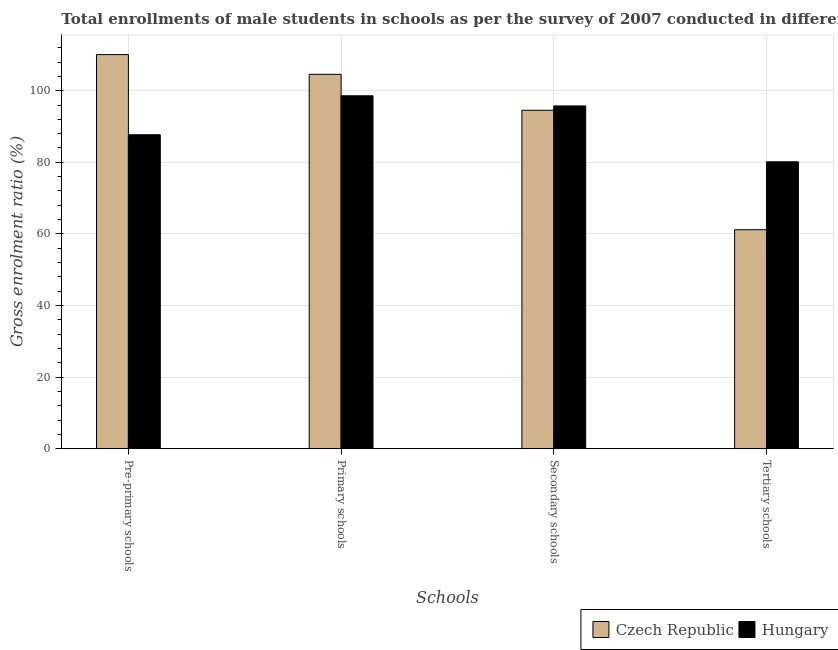How many groups of bars are there?
Offer a very short reply. 4. Are the number of bars on each tick of the X-axis equal?
Offer a very short reply. Yes. How many bars are there on the 1st tick from the right?
Keep it short and to the point. 2. What is the label of the 4th group of bars from the left?
Your answer should be compact. Tertiary schools. What is the gross enrolment ratio(male) in primary schools in Hungary?
Ensure brevity in your answer.  98.58. Across all countries, what is the maximum gross enrolment ratio(male) in primary schools?
Keep it short and to the point. 104.58. Across all countries, what is the minimum gross enrolment ratio(male) in pre-primary schools?
Make the answer very short. 87.69. In which country was the gross enrolment ratio(male) in pre-primary schools maximum?
Ensure brevity in your answer.  Czech Republic. In which country was the gross enrolment ratio(male) in tertiary schools minimum?
Your response must be concise. Czech Republic. What is the total gross enrolment ratio(male) in primary schools in the graph?
Give a very brief answer. 203.16. What is the difference between the gross enrolment ratio(male) in secondary schools in Czech Republic and that in Hungary?
Keep it short and to the point. -1.21. What is the difference between the gross enrolment ratio(male) in primary schools in Czech Republic and the gross enrolment ratio(male) in secondary schools in Hungary?
Offer a very short reply. 8.83. What is the average gross enrolment ratio(male) in pre-primary schools per country?
Keep it short and to the point. 98.89. What is the difference between the gross enrolment ratio(male) in tertiary schools and gross enrolment ratio(male) in pre-primary schools in Hungary?
Your answer should be compact. -7.56. What is the ratio of the gross enrolment ratio(male) in secondary schools in Czech Republic to that in Hungary?
Your answer should be compact. 0.99. Is the gross enrolment ratio(male) in tertiary schools in Czech Republic less than that in Hungary?
Your answer should be very brief. Yes. Is the difference between the gross enrolment ratio(male) in tertiary schools in Czech Republic and Hungary greater than the difference between the gross enrolment ratio(male) in pre-primary schools in Czech Republic and Hungary?
Provide a short and direct response. No. What is the difference between the highest and the second highest gross enrolment ratio(male) in pre-primary schools?
Your answer should be compact. 22.39. What is the difference between the highest and the lowest gross enrolment ratio(male) in secondary schools?
Offer a terse response. 1.21. What does the 1st bar from the left in Pre-primary schools represents?
Ensure brevity in your answer.  Czech Republic. What does the 1st bar from the right in Tertiary schools represents?
Give a very brief answer. Hungary. Is it the case that in every country, the sum of the gross enrolment ratio(male) in pre-primary schools and gross enrolment ratio(male) in primary schools is greater than the gross enrolment ratio(male) in secondary schools?
Provide a short and direct response. Yes. How many bars are there?
Your answer should be compact. 8. Are all the bars in the graph horizontal?
Give a very brief answer. No. How many countries are there in the graph?
Offer a very short reply. 2. Does the graph contain any zero values?
Keep it short and to the point. No. Does the graph contain grids?
Make the answer very short. Yes. Where does the legend appear in the graph?
Ensure brevity in your answer.  Bottom right. How are the legend labels stacked?
Make the answer very short. Horizontal. What is the title of the graph?
Offer a very short reply. Total enrollments of male students in schools as per the survey of 2007 conducted in different countries. Does "Isle of Man" appear as one of the legend labels in the graph?
Your answer should be compact. No. What is the label or title of the X-axis?
Ensure brevity in your answer.  Schools. What is the Gross enrolment ratio (%) in Czech Republic in Pre-primary schools?
Your response must be concise. 110.09. What is the Gross enrolment ratio (%) in Hungary in Pre-primary schools?
Provide a succinct answer. 87.69. What is the Gross enrolment ratio (%) in Czech Republic in Primary schools?
Make the answer very short. 104.58. What is the Gross enrolment ratio (%) in Hungary in Primary schools?
Offer a terse response. 98.58. What is the Gross enrolment ratio (%) of Czech Republic in Secondary schools?
Your response must be concise. 94.53. What is the Gross enrolment ratio (%) in Hungary in Secondary schools?
Ensure brevity in your answer.  95.74. What is the Gross enrolment ratio (%) of Czech Republic in Tertiary schools?
Make the answer very short. 61.17. What is the Gross enrolment ratio (%) of Hungary in Tertiary schools?
Your response must be concise. 80.14. Across all Schools, what is the maximum Gross enrolment ratio (%) of Czech Republic?
Ensure brevity in your answer.  110.09. Across all Schools, what is the maximum Gross enrolment ratio (%) in Hungary?
Give a very brief answer. 98.58. Across all Schools, what is the minimum Gross enrolment ratio (%) in Czech Republic?
Provide a short and direct response. 61.17. Across all Schools, what is the minimum Gross enrolment ratio (%) in Hungary?
Keep it short and to the point. 80.14. What is the total Gross enrolment ratio (%) in Czech Republic in the graph?
Offer a very short reply. 370.37. What is the total Gross enrolment ratio (%) in Hungary in the graph?
Your response must be concise. 362.16. What is the difference between the Gross enrolment ratio (%) in Czech Republic in Pre-primary schools and that in Primary schools?
Your answer should be very brief. 5.51. What is the difference between the Gross enrolment ratio (%) of Hungary in Pre-primary schools and that in Primary schools?
Ensure brevity in your answer.  -10.89. What is the difference between the Gross enrolment ratio (%) of Czech Republic in Pre-primary schools and that in Secondary schools?
Provide a short and direct response. 15.56. What is the difference between the Gross enrolment ratio (%) in Hungary in Pre-primary schools and that in Secondary schools?
Offer a very short reply. -8.05. What is the difference between the Gross enrolment ratio (%) of Czech Republic in Pre-primary schools and that in Tertiary schools?
Your response must be concise. 48.92. What is the difference between the Gross enrolment ratio (%) of Hungary in Pre-primary schools and that in Tertiary schools?
Your response must be concise. 7.56. What is the difference between the Gross enrolment ratio (%) in Czech Republic in Primary schools and that in Secondary schools?
Provide a succinct answer. 10.04. What is the difference between the Gross enrolment ratio (%) of Hungary in Primary schools and that in Secondary schools?
Ensure brevity in your answer.  2.84. What is the difference between the Gross enrolment ratio (%) in Czech Republic in Primary schools and that in Tertiary schools?
Keep it short and to the point. 43.4. What is the difference between the Gross enrolment ratio (%) in Hungary in Primary schools and that in Tertiary schools?
Ensure brevity in your answer.  18.44. What is the difference between the Gross enrolment ratio (%) in Czech Republic in Secondary schools and that in Tertiary schools?
Your answer should be very brief. 33.36. What is the difference between the Gross enrolment ratio (%) in Hungary in Secondary schools and that in Tertiary schools?
Keep it short and to the point. 15.6. What is the difference between the Gross enrolment ratio (%) in Czech Republic in Pre-primary schools and the Gross enrolment ratio (%) in Hungary in Primary schools?
Your response must be concise. 11.51. What is the difference between the Gross enrolment ratio (%) in Czech Republic in Pre-primary schools and the Gross enrolment ratio (%) in Hungary in Secondary schools?
Provide a short and direct response. 14.35. What is the difference between the Gross enrolment ratio (%) of Czech Republic in Pre-primary schools and the Gross enrolment ratio (%) of Hungary in Tertiary schools?
Give a very brief answer. 29.95. What is the difference between the Gross enrolment ratio (%) of Czech Republic in Primary schools and the Gross enrolment ratio (%) of Hungary in Secondary schools?
Provide a short and direct response. 8.83. What is the difference between the Gross enrolment ratio (%) of Czech Republic in Primary schools and the Gross enrolment ratio (%) of Hungary in Tertiary schools?
Provide a succinct answer. 24.44. What is the difference between the Gross enrolment ratio (%) of Czech Republic in Secondary schools and the Gross enrolment ratio (%) of Hungary in Tertiary schools?
Provide a short and direct response. 14.39. What is the average Gross enrolment ratio (%) in Czech Republic per Schools?
Your answer should be compact. 92.59. What is the average Gross enrolment ratio (%) in Hungary per Schools?
Provide a short and direct response. 90.54. What is the difference between the Gross enrolment ratio (%) in Czech Republic and Gross enrolment ratio (%) in Hungary in Pre-primary schools?
Your response must be concise. 22.39. What is the difference between the Gross enrolment ratio (%) of Czech Republic and Gross enrolment ratio (%) of Hungary in Primary schools?
Offer a very short reply. 5.99. What is the difference between the Gross enrolment ratio (%) in Czech Republic and Gross enrolment ratio (%) in Hungary in Secondary schools?
Offer a terse response. -1.21. What is the difference between the Gross enrolment ratio (%) in Czech Republic and Gross enrolment ratio (%) in Hungary in Tertiary schools?
Your answer should be compact. -18.97. What is the ratio of the Gross enrolment ratio (%) in Czech Republic in Pre-primary schools to that in Primary schools?
Your response must be concise. 1.05. What is the ratio of the Gross enrolment ratio (%) in Hungary in Pre-primary schools to that in Primary schools?
Provide a succinct answer. 0.89. What is the ratio of the Gross enrolment ratio (%) of Czech Republic in Pre-primary schools to that in Secondary schools?
Offer a very short reply. 1.16. What is the ratio of the Gross enrolment ratio (%) of Hungary in Pre-primary schools to that in Secondary schools?
Give a very brief answer. 0.92. What is the ratio of the Gross enrolment ratio (%) in Czech Republic in Pre-primary schools to that in Tertiary schools?
Your answer should be very brief. 1.8. What is the ratio of the Gross enrolment ratio (%) in Hungary in Pre-primary schools to that in Tertiary schools?
Your answer should be very brief. 1.09. What is the ratio of the Gross enrolment ratio (%) of Czech Republic in Primary schools to that in Secondary schools?
Provide a short and direct response. 1.11. What is the ratio of the Gross enrolment ratio (%) in Hungary in Primary schools to that in Secondary schools?
Ensure brevity in your answer.  1.03. What is the ratio of the Gross enrolment ratio (%) of Czech Republic in Primary schools to that in Tertiary schools?
Give a very brief answer. 1.71. What is the ratio of the Gross enrolment ratio (%) of Hungary in Primary schools to that in Tertiary schools?
Offer a terse response. 1.23. What is the ratio of the Gross enrolment ratio (%) in Czech Republic in Secondary schools to that in Tertiary schools?
Provide a short and direct response. 1.55. What is the ratio of the Gross enrolment ratio (%) of Hungary in Secondary schools to that in Tertiary schools?
Provide a succinct answer. 1.19. What is the difference between the highest and the second highest Gross enrolment ratio (%) in Czech Republic?
Ensure brevity in your answer.  5.51. What is the difference between the highest and the second highest Gross enrolment ratio (%) in Hungary?
Offer a terse response. 2.84. What is the difference between the highest and the lowest Gross enrolment ratio (%) of Czech Republic?
Keep it short and to the point. 48.92. What is the difference between the highest and the lowest Gross enrolment ratio (%) of Hungary?
Ensure brevity in your answer.  18.44. 